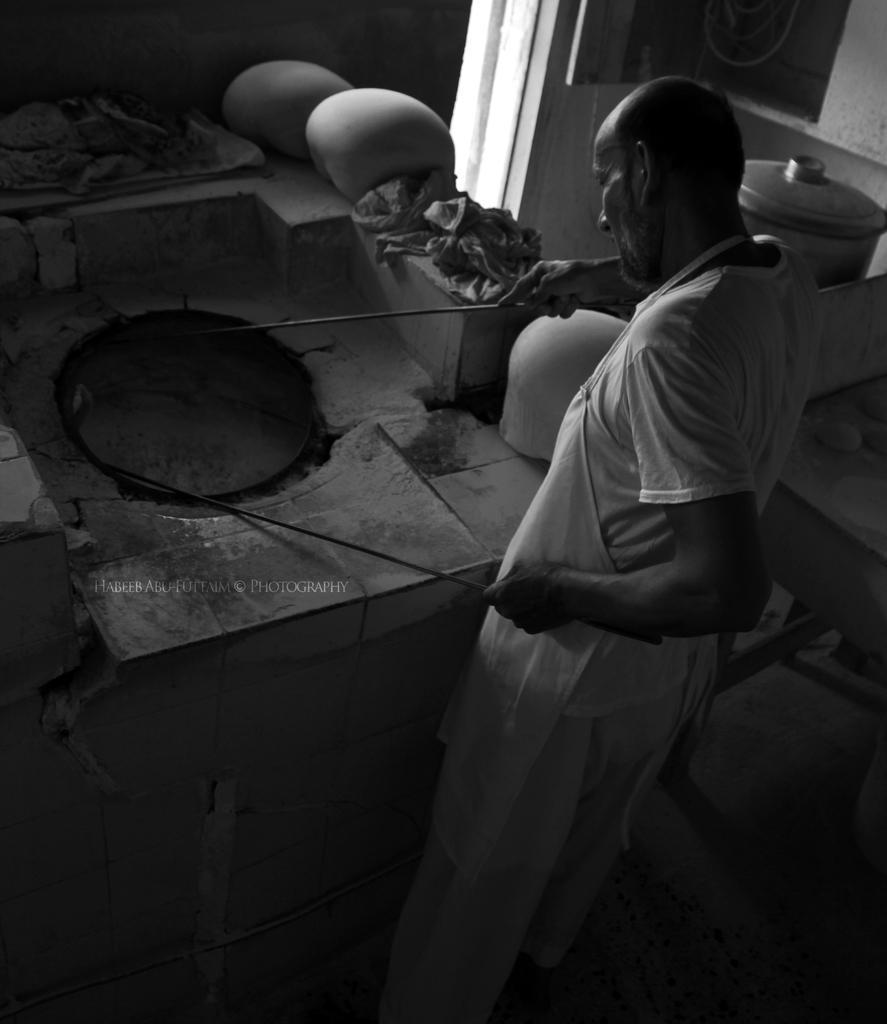Can you describe this image briefly? This is a black and white picture. In this picture we can see a person holding sticks in his hands. We can see a platform, kitchen vessels and other objects. We can see some text on the left side. 